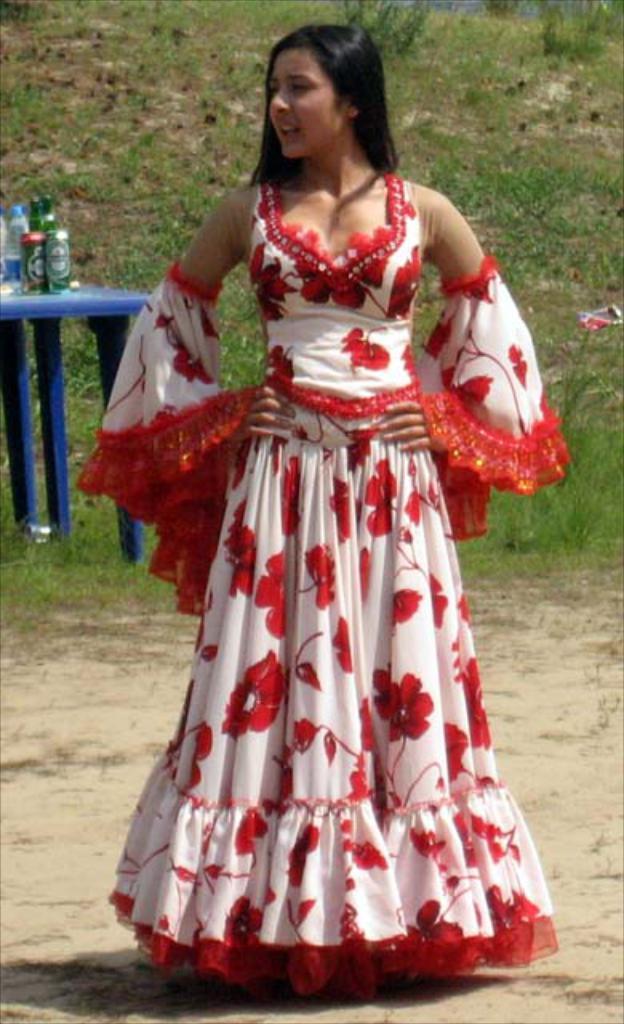In one or two sentences, can you explain what this image depicts? In this picture we can see woman standing wore a beautiful dress and in the background we can see grass, table and on table we can see bottle, tin. 